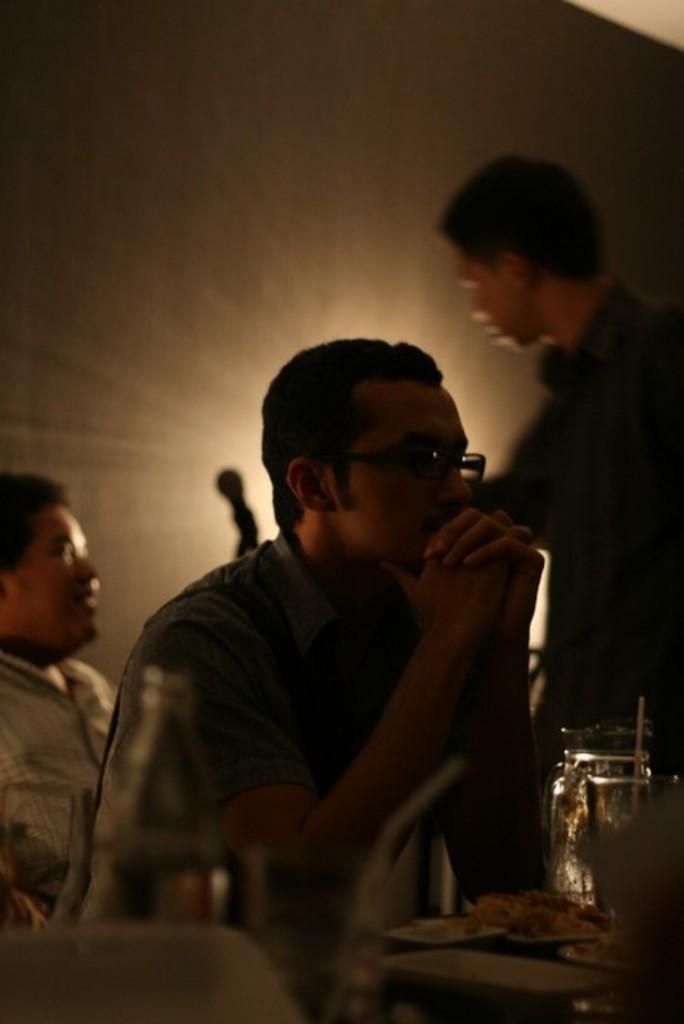Describe this image in one or two sentences. In this image, there are a few people. We can see some glass objects and food items. We can see the background. We can also see some objects at the bottom. 